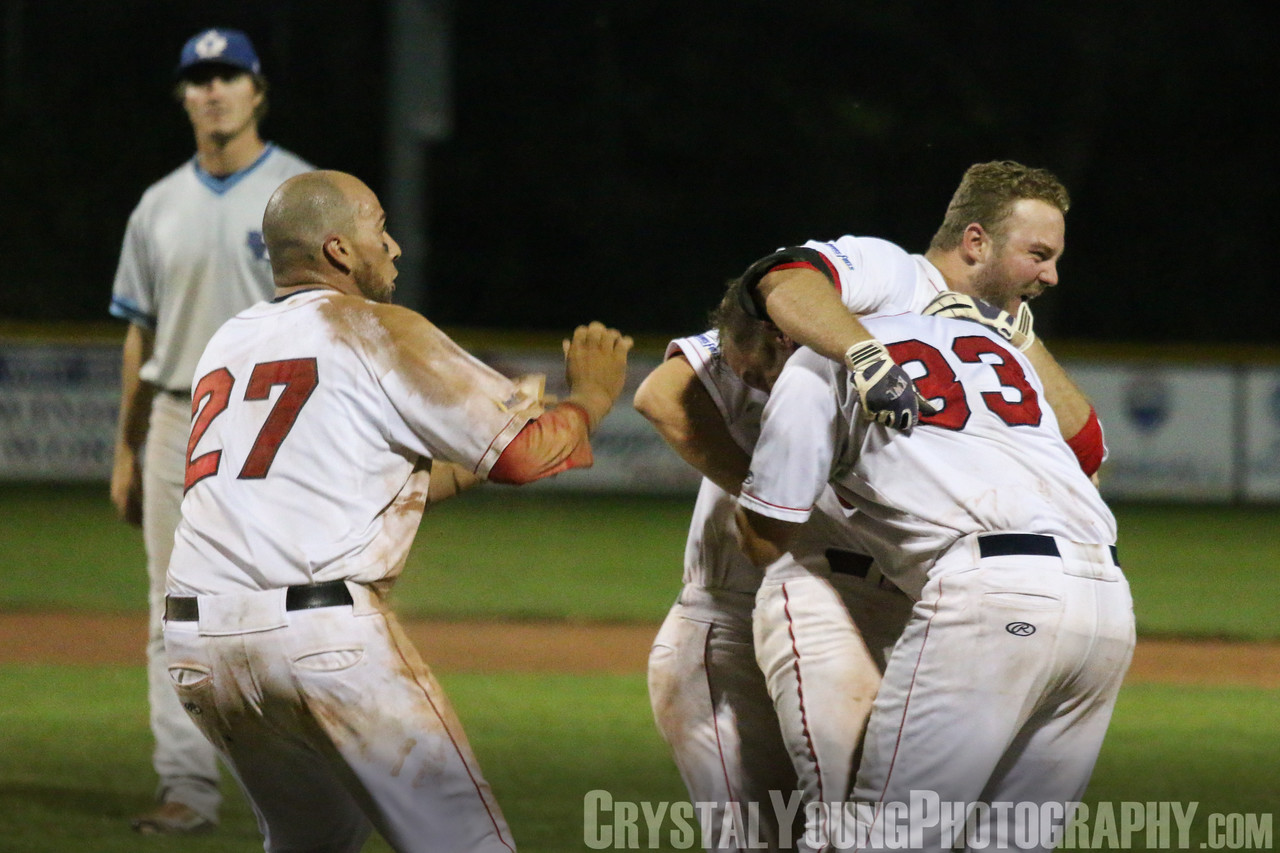The players are celebrating, but let's delve into a more personal side by exploring one of the players' thoughts during this moment. As the final play unfolds and the game-winning run is scored, Player #33 feels a rush of emotions flood over him. Years of dedication, countless hours of practice, and the highs and lows of the season culminate in this singular, triumphant moment. His mind races with memories of those who supported him, the sacrifices he made, and the sheer joy of achieving something great with his teammates. In this embrace, he feels an overwhelming sense of camaraderie and unity, knowing that this victory is shared with those who believed in each other and gave their all. This win is more than just a number on a scoreboard; it is a testament to their collective perseverance and spirit. 